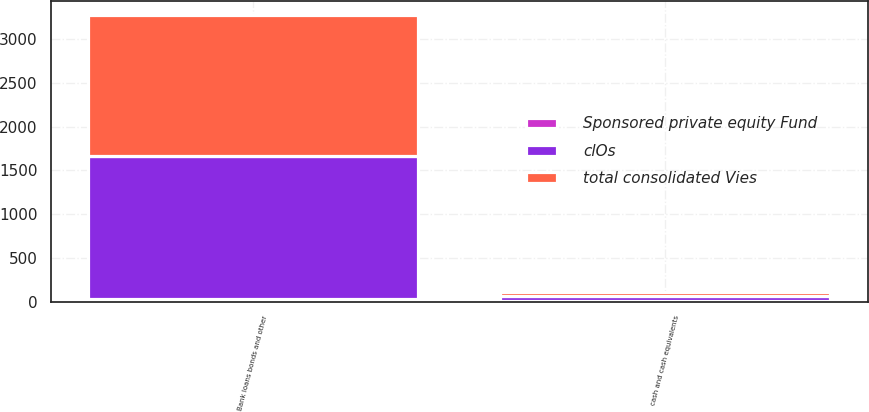Convert chart to OTSL. <chart><loc_0><loc_0><loc_500><loc_500><stacked_bar_chart><ecel><fcel>cash and cash equivalents<fcel>Bank loans bonds and other<nl><fcel>total consolidated Vies<fcel>47<fcel>1608<nl><fcel>Sponsored private equity Fund<fcel>7<fcel>31<nl><fcel>clOs<fcel>54<fcel>1639<nl></chart> 